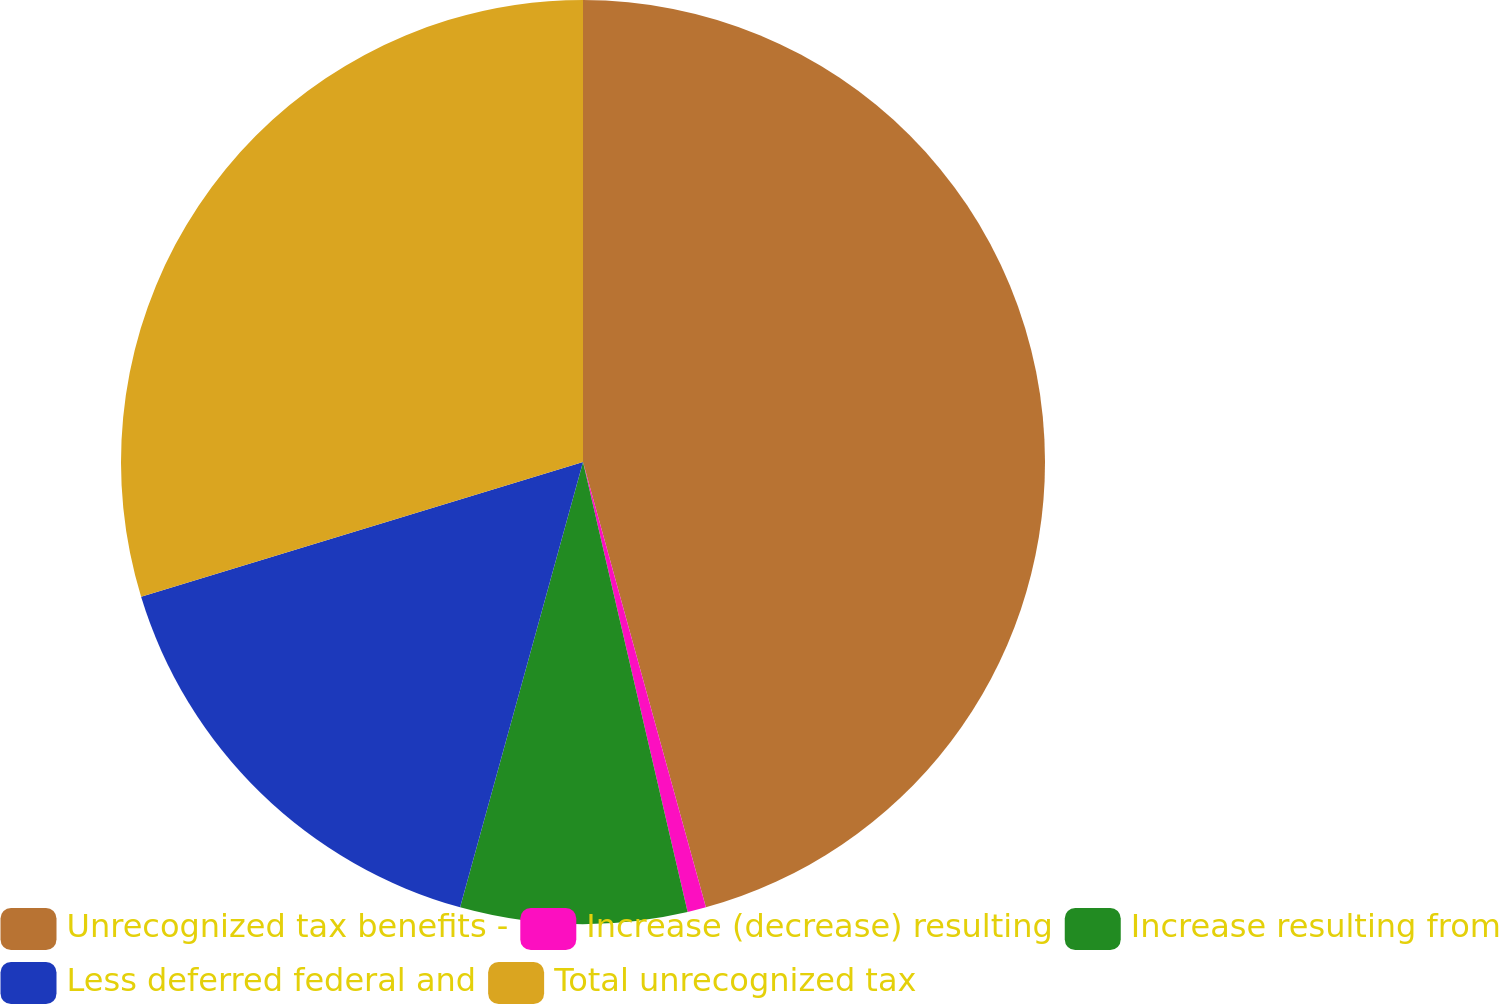<chart> <loc_0><loc_0><loc_500><loc_500><pie_chart><fcel>Unrecognized tax benefits -<fcel>Increase (decrease) resulting<fcel>Increase resulting from<fcel>Less deferred federal and<fcel>Total unrecognized tax<nl><fcel>45.71%<fcel>0.65%<fcel>7.92%<fcel>16.0%<fcel>29.71%<nl></chart> 